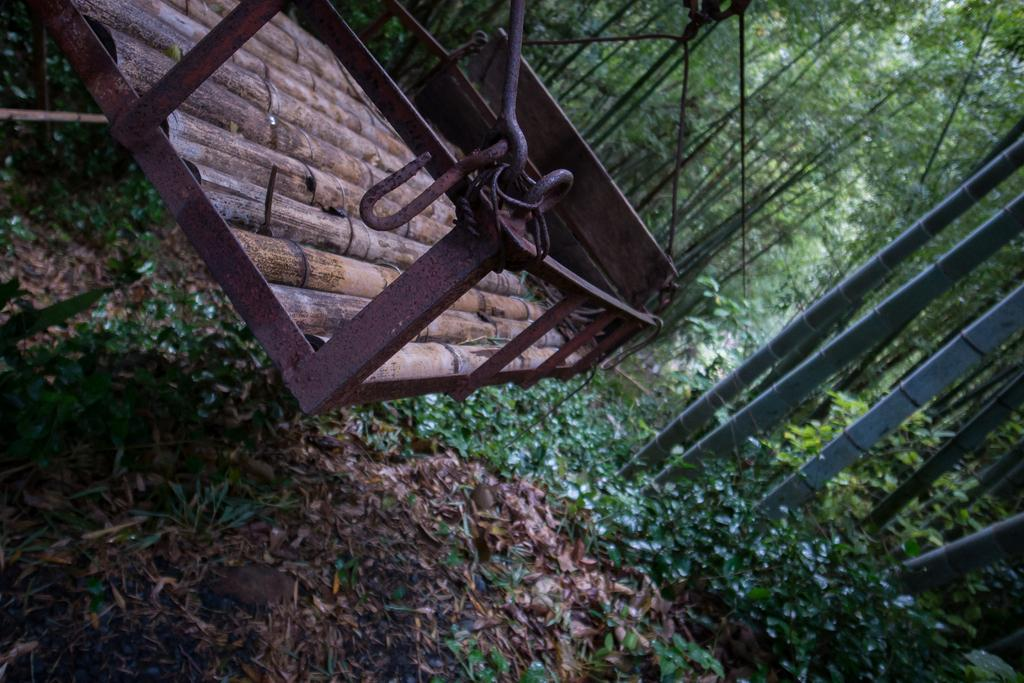What is the main object in the foreground of the image? There is a cradle in the foreground of the image. Where is the cradle located in relation to the image? The cradle is on the top side of the image. What can be seen surrounding the cradle? There are trees and plants around the cradle. What type of tray is being used to hold the beetle in the image? There is no tray or beetle present in the image; it features a cradle surrounded by trees and plants. 